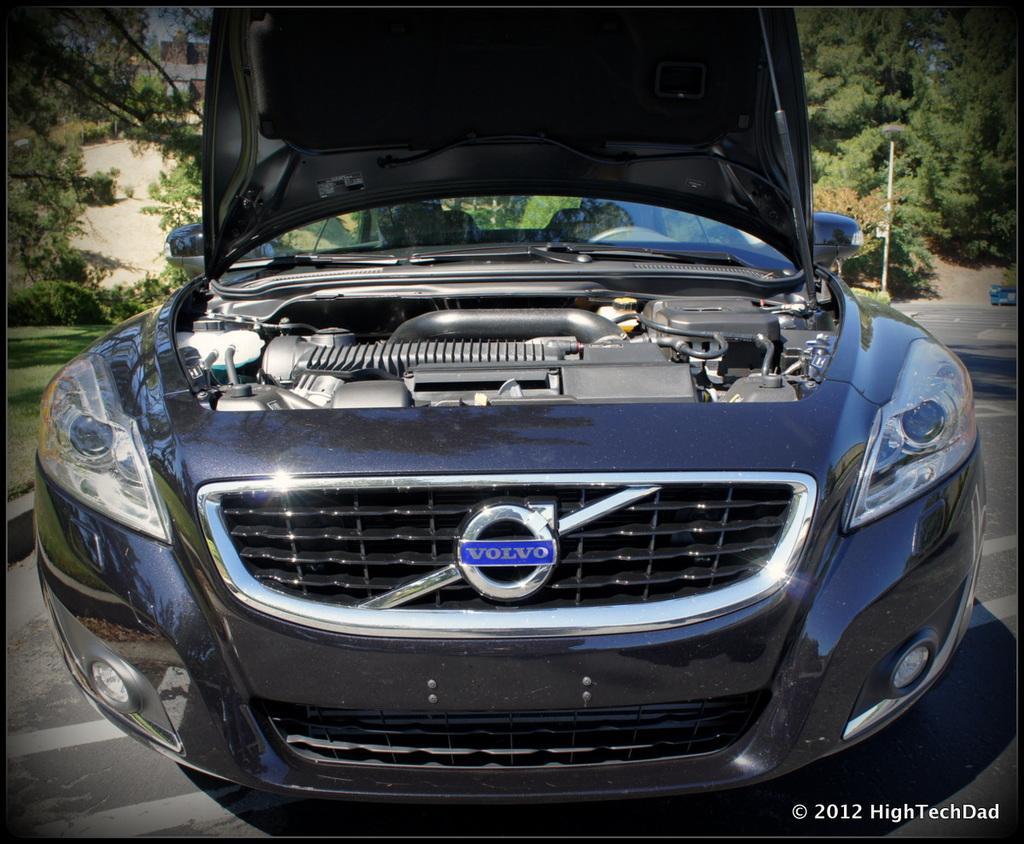Can you describe this image briefly? In this picture I can see I van see vehicle on the road, side I can see some trees, grass and buildings. 